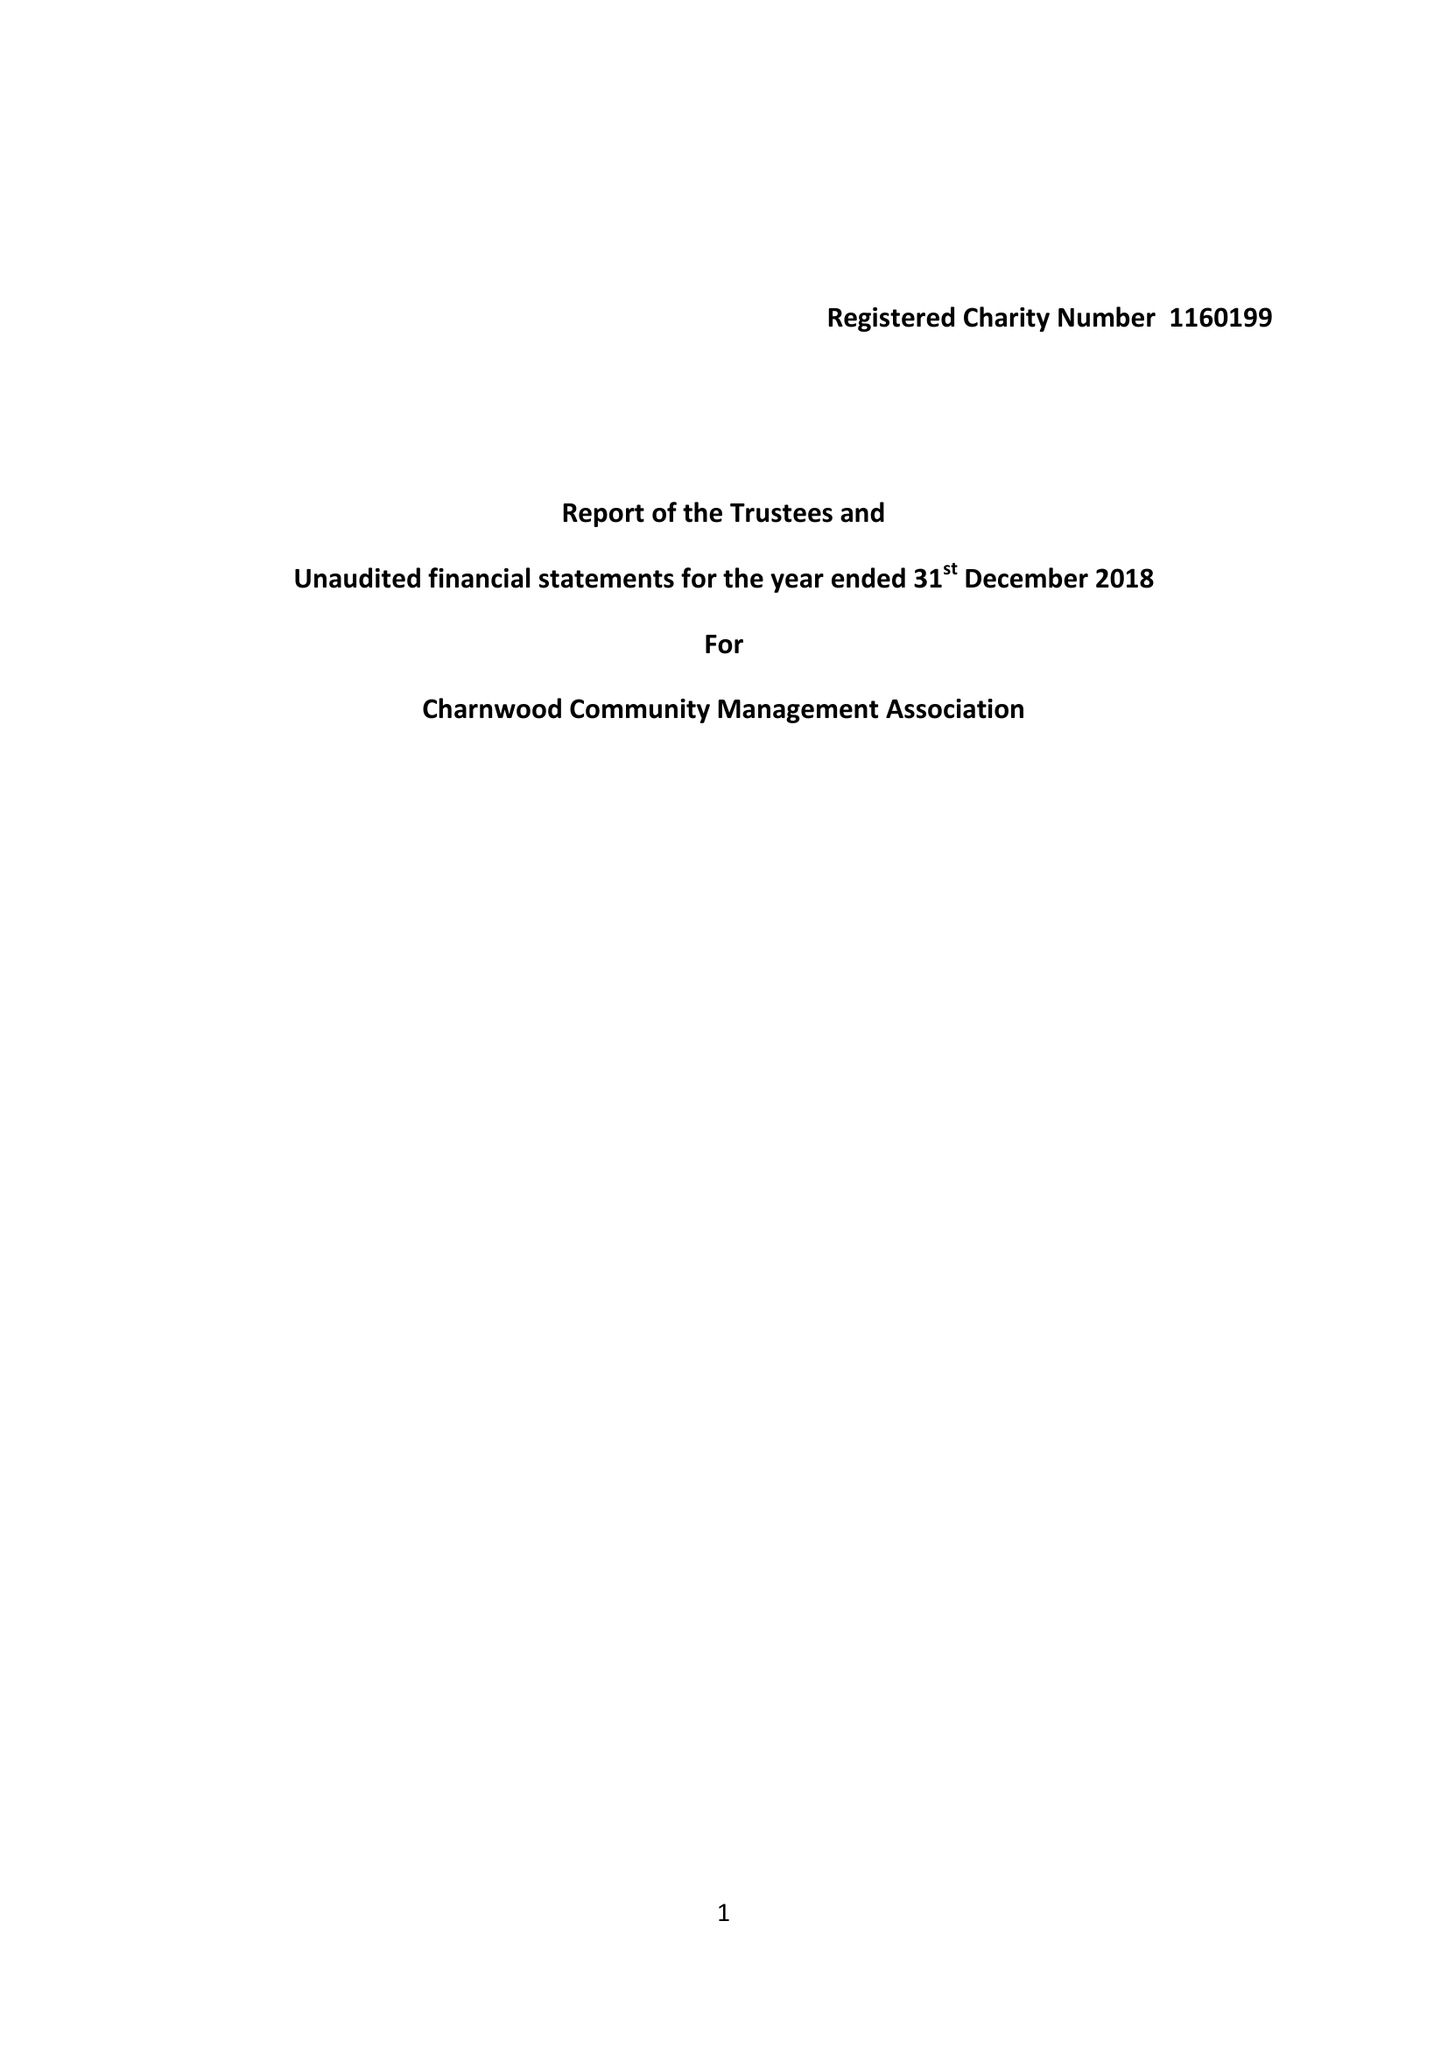What is the value for the income_annually_in_british_pounds?
Answer the question using a single word or phrase. 157.00 